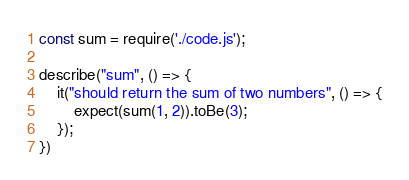<code> <loc_0><loc_0><loc_500><loc_500><_JavaScript_>const sum = require('./code.js');

describe("sum", () => {
    it("should return the sum of two numbers", () => {
        expect(sum(1, 2)).toBe(3);
    });
})</code> 